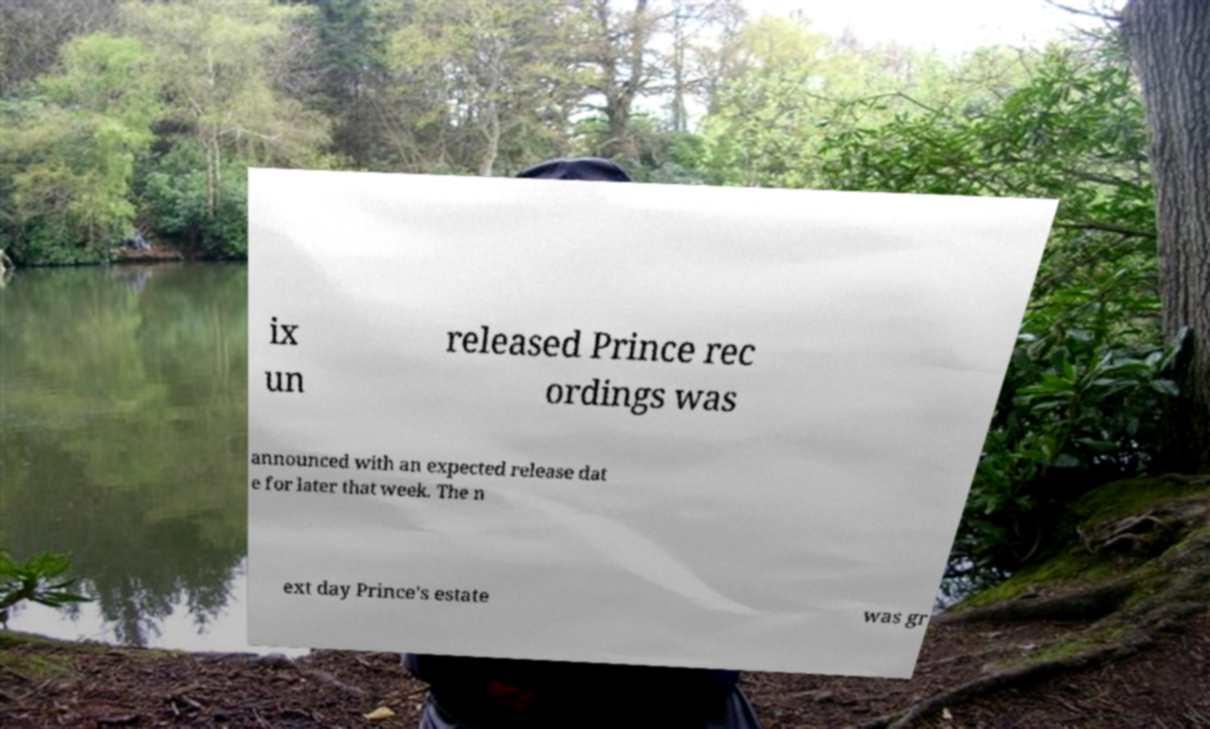I need the written content from this picture converted into text. Can you do that? ix un released Prince rec ordings was announced with an expected release dat e for later that week. The n ext day Prince's estate was gr 